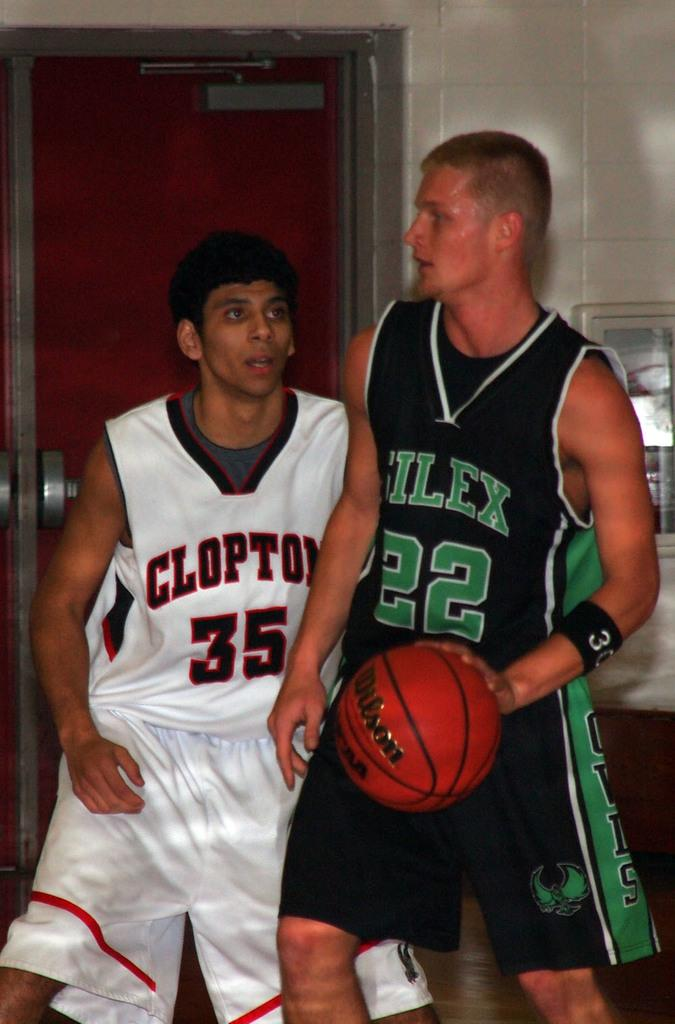<image>
Write a terse but informative summary of the picture. Two basketball players, one with 22 on his shirt, the other has 35. 